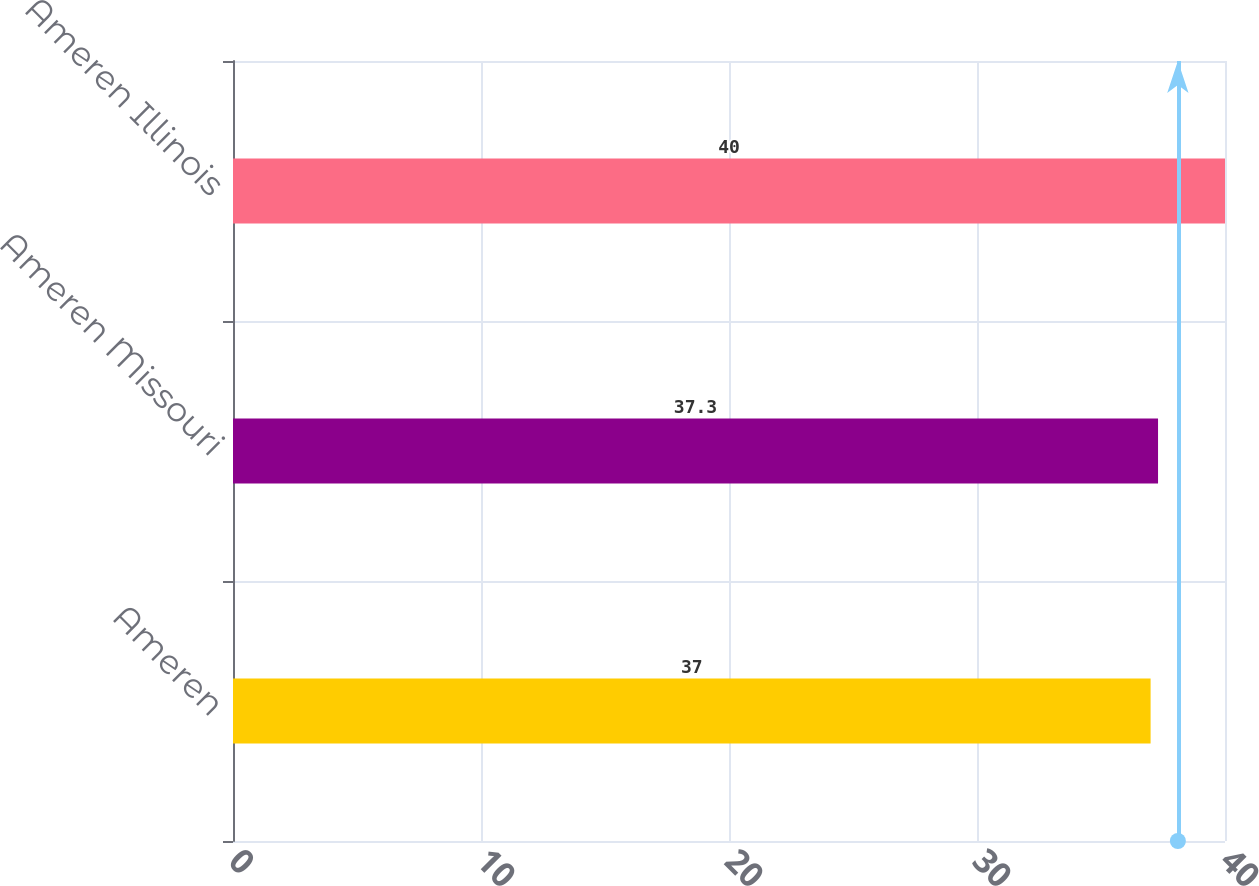<chart> <loc_0><loc_0><loc_500><loc_500><bar_chart><fcel>Ameren<fcel>Ameren Missouri<fcel>Ameren Illinois<nl><fcel>37<fcel>37.3<fcel>40<nl></chart> 